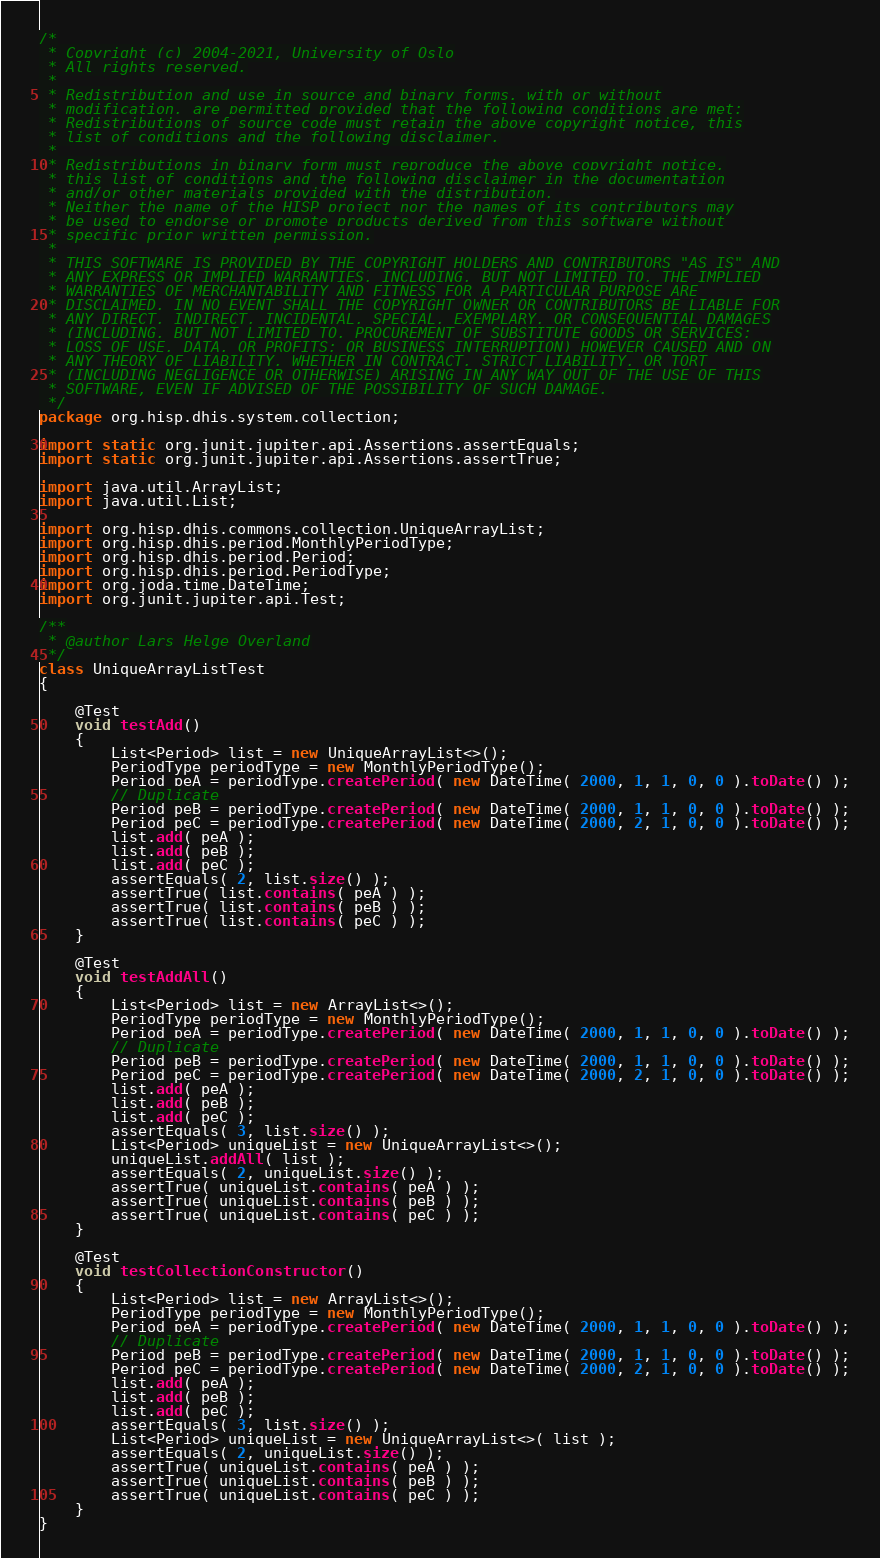<code> <loc_0><loc_0><loc_500><loc_500><_Java_>/*
 * Copyright (c) 2004-2021, University of Oslo
 * All rights reserved.
 *
 * Redistribution and use in source and binary forms, with or without
 * modification, are permitted provided that the following conditions are met:
 * Redistributions of source code must retain the above copyright notice, this
 * list of conditions and the following disclaimer.
 *
 * Redistributions in binary form must reproduce the above copyright notice,
 * this list of conditions and the following disclaimer in the documentation
 * and/or other materials provided with the distribution.
 * Neither the name of the HISP project nor the names of its contributors may
 * be used to endorse or promote products derived from this software without
 * specific prior written permission.
 *
 * THIS SOFTWARE IS PROVIDED BY THE COPYRIGHT HOLDERS AND CONTRIBUTORS "AS IS" AND
 * ANY EXPRESS OR IMPLIED WARRANTIES, INCLUDING, BUT NOT LIMITED TO, THE IMPLIED
 * WARRANTIES OF MERCHANTABILITY AND FITNESS FOR A PARTICULAR PURPOSE ARE
 * DISCLAIMED. IN NO EVENT SHALL THE COPYRIGHT OWNER OR CONTRIBUTORS BE LIABLE FOR
 * ANY DIRECT, INDIRECT, INCIDENTAL, SPECIAL, EXEMPLARY, OR CONSEQUENTIAL DAMAGES
 * (INCLUDING, BUT NOT LIMITED TO, PROCUREMENT OF SUBSTITUTE GOODS OR SERVICES;
 * LOSS OF USE, DATA, OR PROFITS; OR BUSINESS INTERRUPTION) HOWEVER CAUSED AND ON
 * ANY THEORY OF LIABILITY, WHETHER IN CONTRACT, STRICT LIABILITY, OR TORT
 * (INCLUDING NEGLIGENCE OR OTHERWISE) ARISING IN ANY WAY OUT OF THE USE OF THIS
 * SOFTWARE, EVEN IF ADVISED OF THE POSSIBILITY OF SUCH DAMAGE.
 */
package org.hisp.dhis.system.collection;

import static org.junit.jupiter.api.Assertions.assertEquals;
import static org.junit.jupiter.api.Assertions.assertTrue;

import java.util.ArrayList;
import java.util.List;

import org.hisp.dhis.commons.collection.UniqueArrayList;
import org.hisp.dhis.period.MonthlyPeriodType;
import org.hisp.dhis.period.Period;
import org.hisp.dhis.period.PeriodType;
import org.joda.time.DateTime;
import org.junit.jupiter.api.Test;

/**
 * @author Lars Helge Overland
 */
class UniqueArrayListTest
{

    @Test
    void testAdd()
    {
        List<Period> list = new UniqueArrayList<>();
        PeriodType periodType = new MonthlyPeriodType();
        Period peA = periodType.createPeriod( new DateTime( 2000, 1, 1, 0, 0 ).toDate() );
        // Duplicate
        Period peB = periodType.createPeriod( new DateTime( 2000, 1, 1, 0, 0 ).toDate() );
        Period peC = periodType.createPeriod( new DateTime( 2000, 2, 1, 0, 0 ).toDate() );
        list.add( peA );
        list.add( peB );
        list.add( peC );
        assertEquals( 2, list.size() );
        assertTrue( list.contains( peA ) );
        assertTrue( list.contains( peB ) );
        assertTrue( list.contains( peC ) );
    }

    @Test
    void testAddAll()
    {
        List<Period> list = new ArrayList<>();
        PeriodType periodType = new MonthlyPeriodType();
        Period peA = periodType.createPeriod( new DateTime( 2000, 1, 1, 0, 0 ).toDate() );
        // Duplicate
        Period peB = periodType.createPeriod( new DateTime( 2000, 1, 1, 0, 0 ).toDate() );
        Period peC = periodType.createPeriod( new DateTime( 2000, 2, 1, 0, 0 ).toDate() );
        list.add( peA );
        list.add( peB );
        list.add( peC );
        assertEquals( 3, list.size() );
        List<Period> uniqueList = new UniqueArrayList<>();
        uniqueList.addAll( list );
        assertEquals( 2, uniqueList.size() );
        assertTrue( uniqueList.contains( peA ) );
        assertTrue( uniqueList.contains( peB ) );
        assertTrue( uniqueList.contains( peC ) );
    }

    @Test
    void testCollectionConstructor()
    {
        List<Period> list = new ArrayList<>();
        PeriodType periodType = new MonthlyPeriodType();
        Period peA = periodType.createPeriod( new DateTime( 2000, 1, 1, 0, 0 ).toDate() );
        // Duplicate
        Period peB = periodType.createPeriod( new DateTime( 2000, 1, 1, 0, 0 ).toDate() );
        Period peC = periodType.createPeriod( new DateTime( 2000, 2, 1, 0, 0 ).toDate() );
        list.add( peA );
        list.add( peB );
        list.add( peC );
        assertEquals( 3, list.size() );
        List<Period> uniqueList = new UniqueArrayList<>( list );
        assertEquals( 2, uniqueList.size() );
        assertTrue( uniqueList.contains( peA ) );
        assertTrue( uniqueList.contains( peB ) );
        assertTrue( uniqueList.contains( peC ) );
    }
}
</code> 